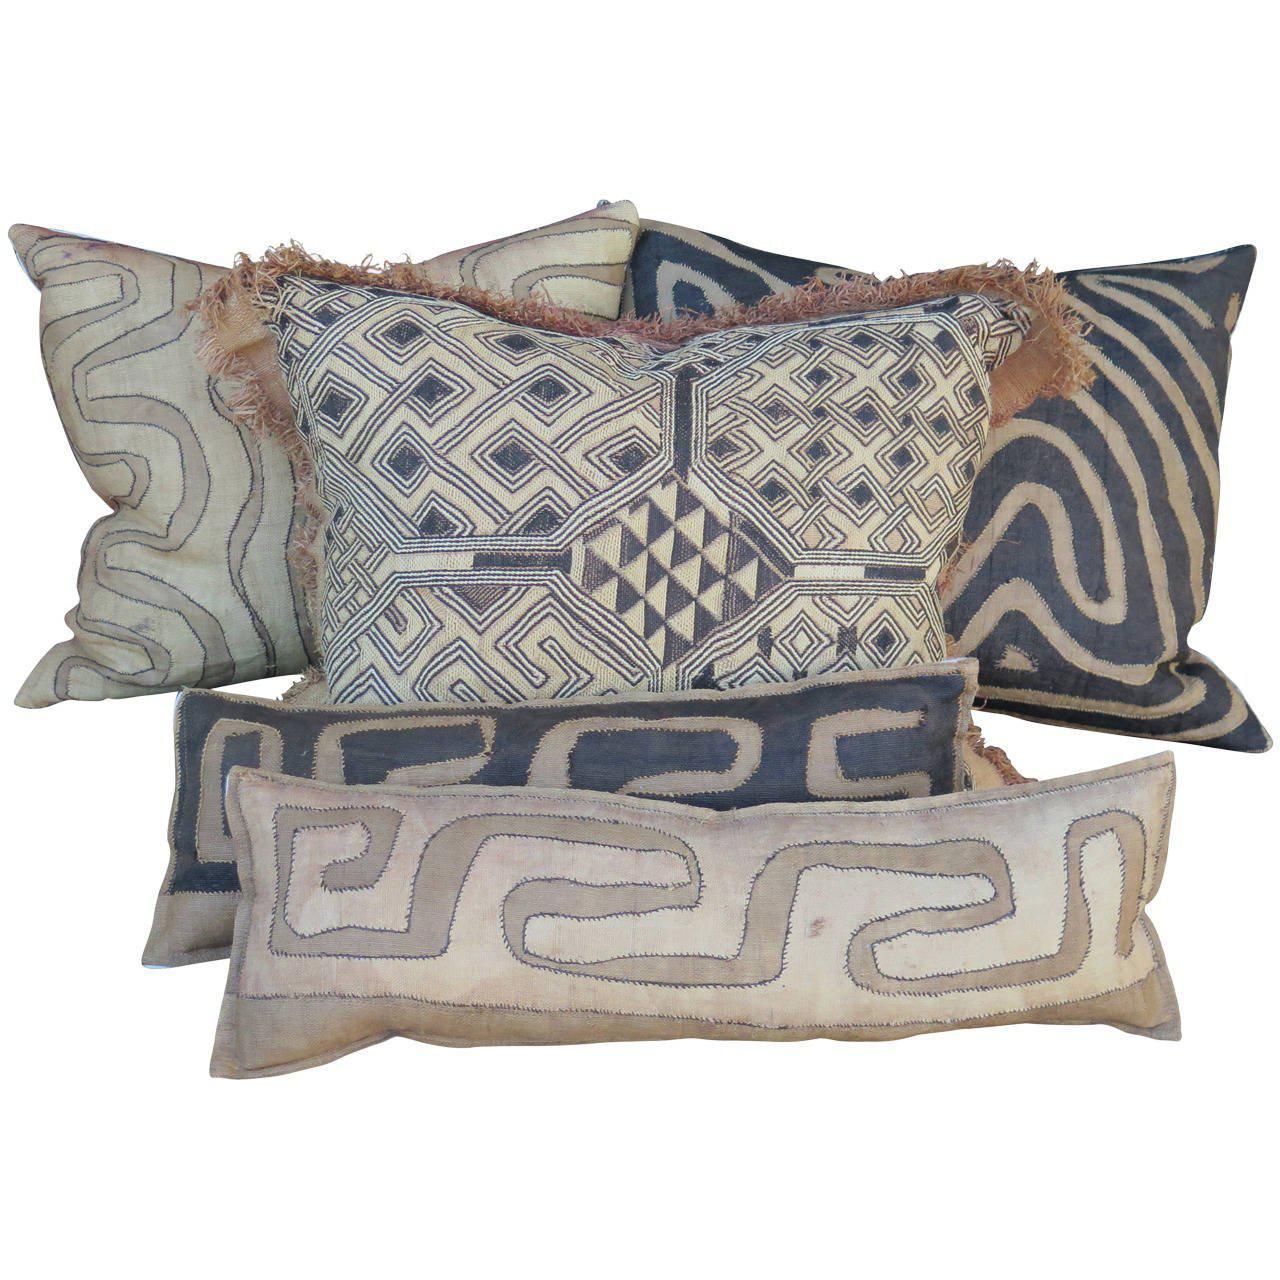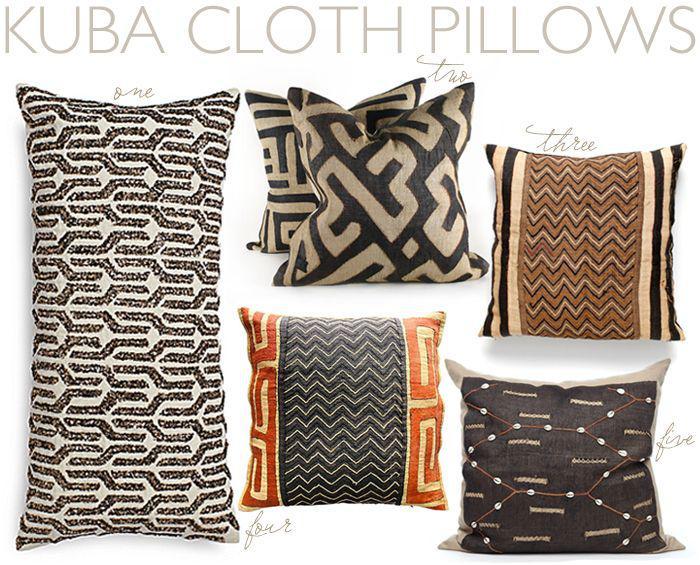The first image is the image on the left, the second image is the image on the right. Analyze the images presented: Is the assertion "There are no more than two pillows in each image." valid? Answer yes or no. No. 